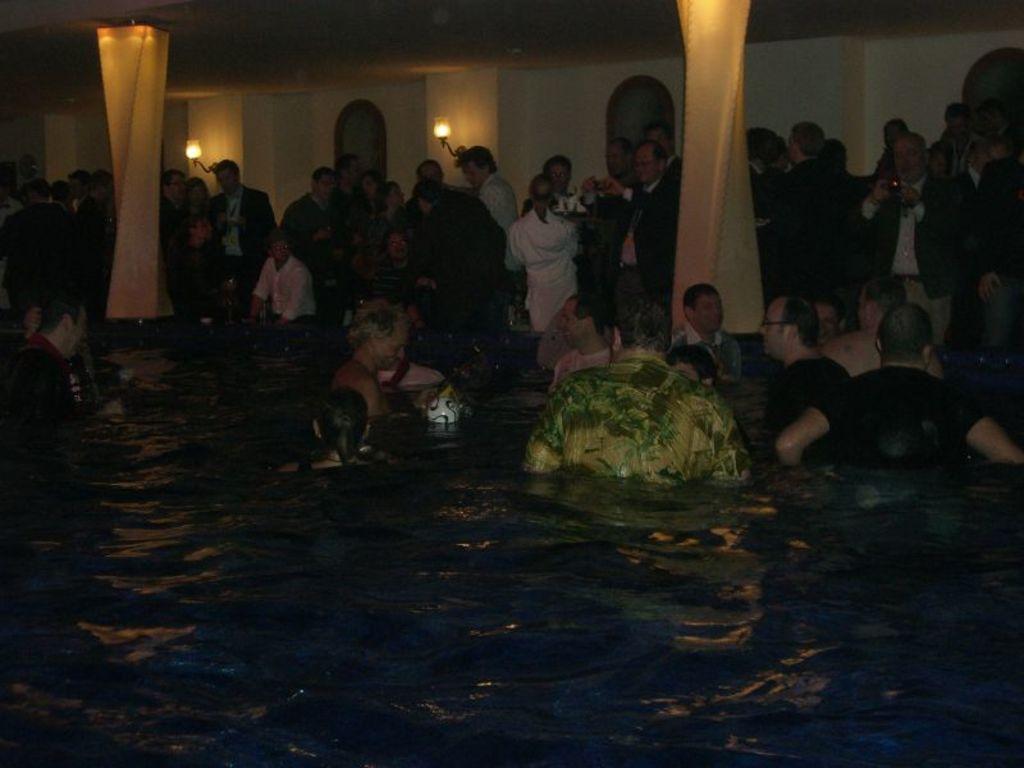Can you describe this image briefly? In this image I can see there is a swimming pool and there are few people in the pool, there are few others standing in the background of the image and there are having drinks and there are two lights attached to the wall and there are two pillars with lights. 